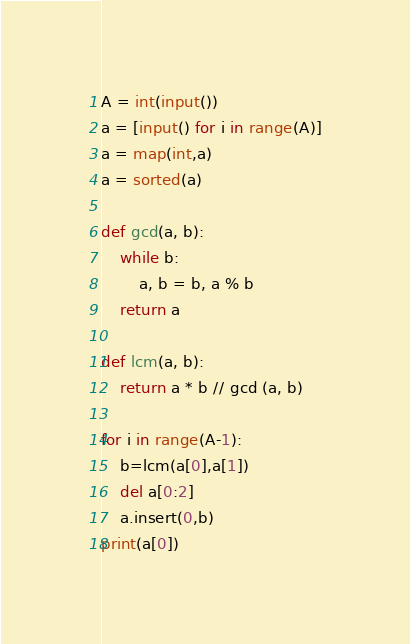<code> <loc_0><loc_0><loc_500><loc_500><_Python_>A = int(input())
a = [input() for i in range(A)]
a = map(int,a)
a = sorted(a)

def gcd(a, b):
	while b:
		a, b = b, a % b
	return a

def lcm(a, b):
	return a * b // gcd (a, b)

for i in range(A-1):
    b=lcm(a[0],a[1])
    del a[0:2]
    a.insert(0,b)
print(a[0])
</code> 